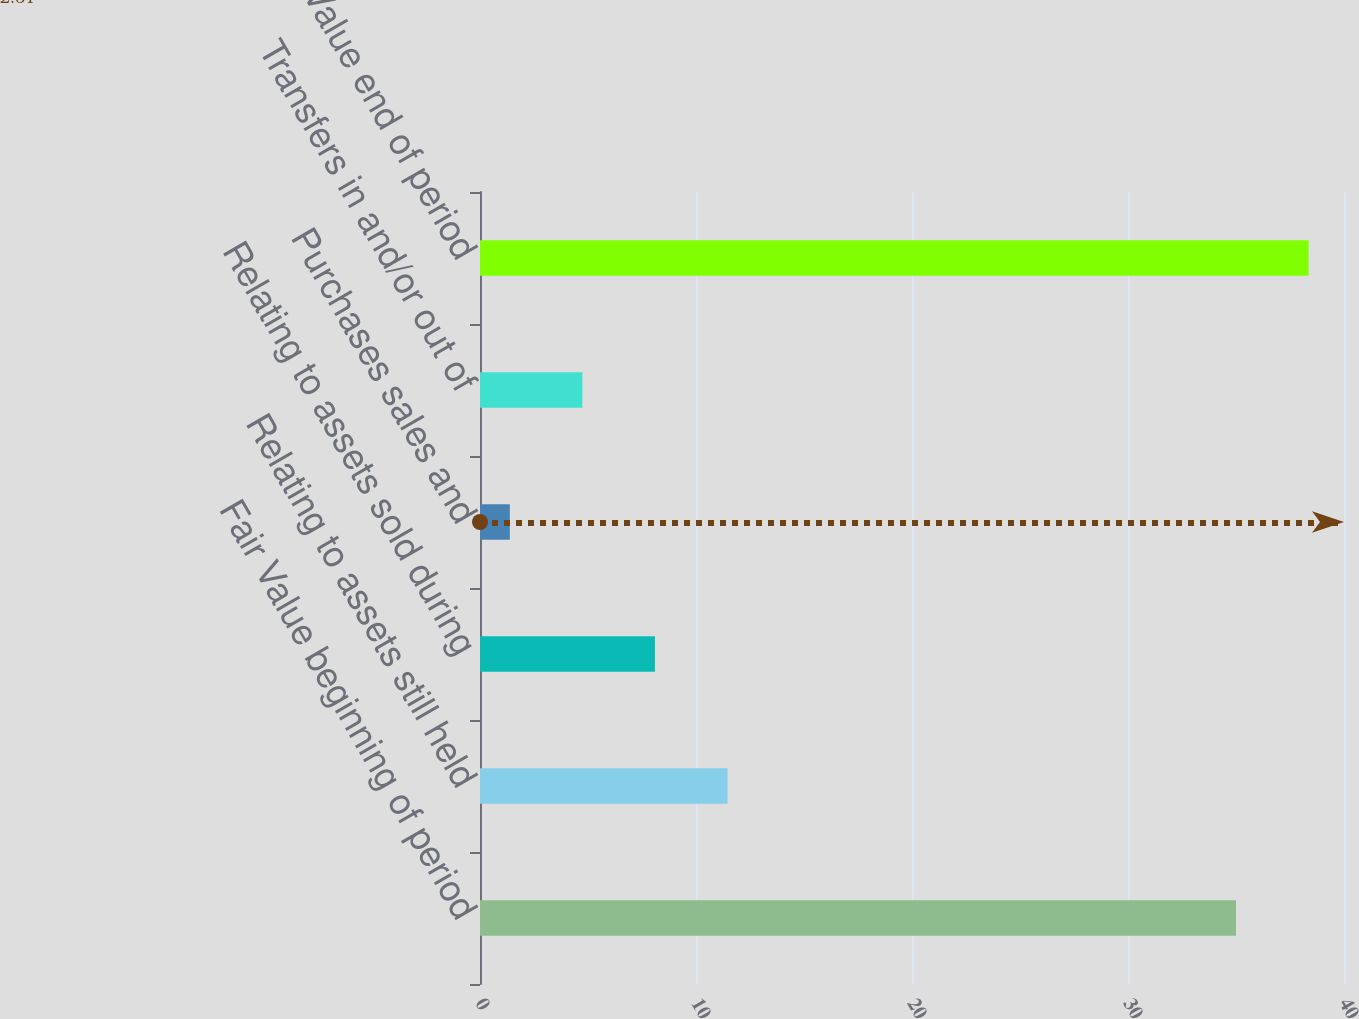Convert chart to OTSL. <chart><loc_0><loc_0><loc_500><loc_500><bar_chart><fcel>Fair Value beginning of period<fcel>Relating to assets still held<fcel>Relating to assets sold during<fcel>Purchases sales and<fcel>Transfers in and/or out of<fcel>Fair Value end of period<nl><fcel>35<fcel>11.46<fcel>8.1<fcel>1.38<fcel>4.74<fcel>38.36<nl></chart> 